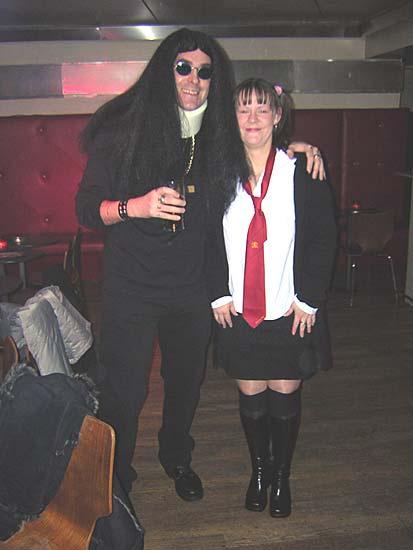What color are the boots?
Short answer required. Black. Is the woman shorter than the man?
Write a very short answer. Yes. Is she meeting this celebrity for the first time?
Answer briefly. Yes. What color is the tie that the woman is wearing?
Quick response, please. Red. 